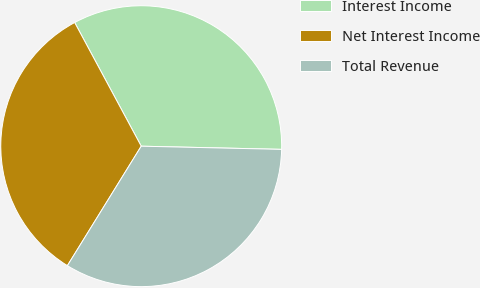<chart> <loc_0><loc_0><loc_500><loc_500><pie_chart><fcel>Interest Income<fcel>Net Interest Income<fcel>Total Revenue<nl><fcel>33.22%<fcel>33.33%<fcel>33.45%<nl></chart> 